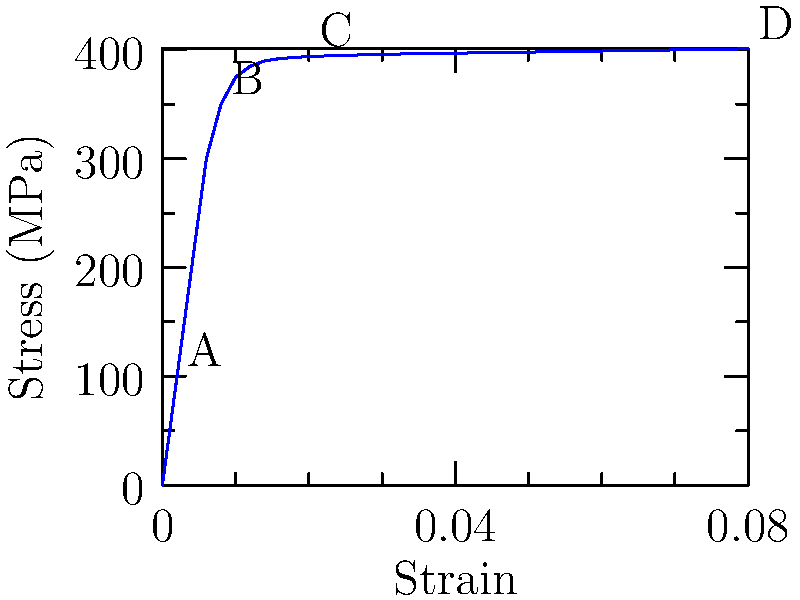In the stress-strain curve shown for a typical ductile material, identify the point that represents the yield strength. What physical change occurs in the material at this point, and how does it relate to Hooke's law? To answer this question, let's analyze the stress-strain curve step-by-step:

1. The stress-strain curve has four distinct regions, labeled A, B, C, and D.

2. Region A to B: This is the linear elastic region, where stress is directly proportional to strain. This region follows Hooke's law, expressed as $\sigma = E\epsilon$, where $\sigma$ is stress, $E$ is Young's modulus, and $\epsilon$ is strain.

3. Point B: This point represents the yield strength of the material. It's the point where the curve starts to deviate from linearity.

4. At the yield strength:
   a) The material begins to deform plastically.
   b) Permanent deformation occurs, meaning the material won't return to its original shape when the stress is removed.
   c) Dislocations in the crystal structure of the material begin to move.

5. Beyond point B: The material enters the plastic deformation region, where Hooke's law no longer applies.

6. The yield strength (point B) marks the transition from elastic to plastic behavior. It's crucial in engineering design as it determines the maximum stress a material can withstand without permanent deformation.

7. Relation to Hooke's law: The yield strength is the upper limit of stress for which Hooke's law is valid. Beyond this point, the simple linear relationship between stress and strain breaks down.
Answer: Point B; onset of plastic deformation; upper limit of Hooke's law applicability 